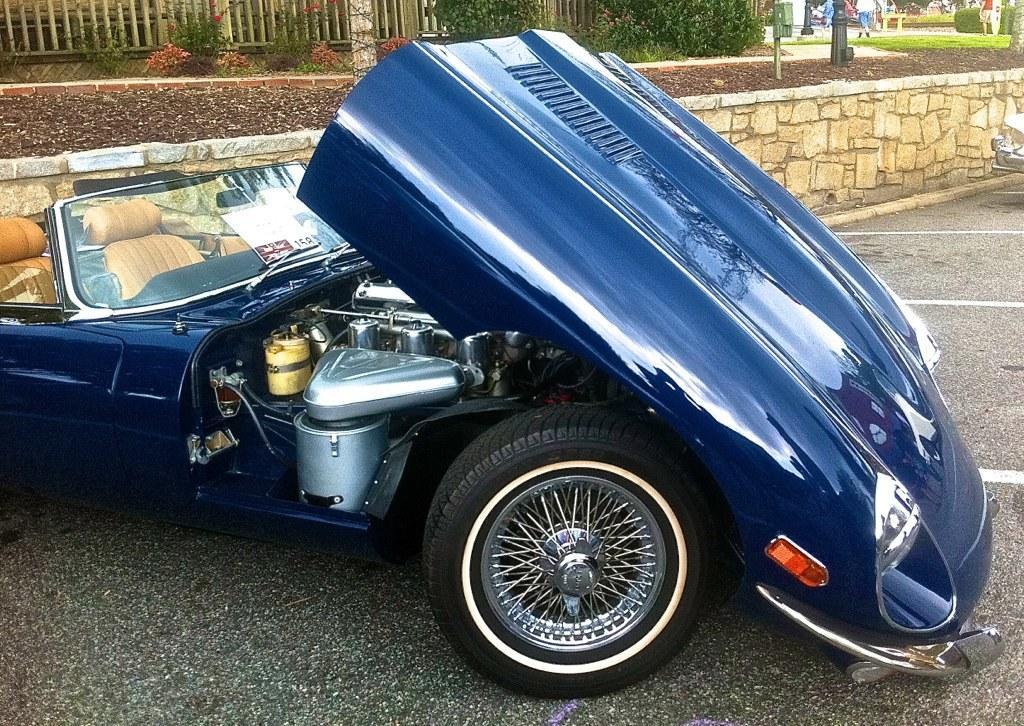How would you summarize this image in a sentence or two? In this image in the center there is one vehicle, at the bottom there is a road. And in the background there is a fence, trees and some plants and a wall. 